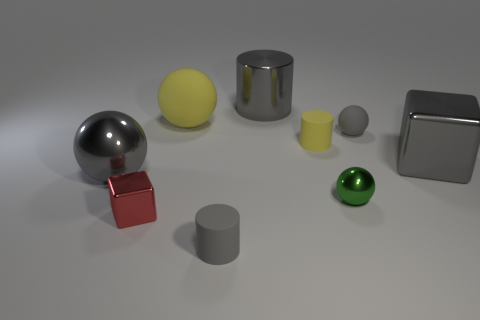Is the material of the gray cylinder left of the large metallic cylinder the same as the gray block?
Your response must be concise. No. What color is the cylinder that is in front of the big matte thing and behind the small green metal sphere?
Provide a short and direct response. Yellow. There is a big sphere to the right of the red shiny thing; how many metallic cubes are on the right side of it?
Give a very brief answer. 1. There is another large thing that is the same shape as the red metal object; what is it made of?
Give a very brief answer. Metal. What color is the large cylinder?
Offer a very short reply. Gray. How many objects are large purple metal cylinders or big yellow things?
Offer a very short reply. 1. There is a tiny gray rubber thing behind the matte object in front of the small yellow thing; what shape is it?
Ensure brevity in your answer.  Sphere. How many other things are there of the same material as the tiny yellow object?
Your answer should be compact. 3. Is the big yellow object made of the same material as the cylinder that is on the left side of the big gray cylinder?
Give a very brief answer. Yes. How many objects are small gray matte objects behind the tiny metal sphere or gray shiny things to the left of the tiny gray ball?
Your response must be concise. 3. 